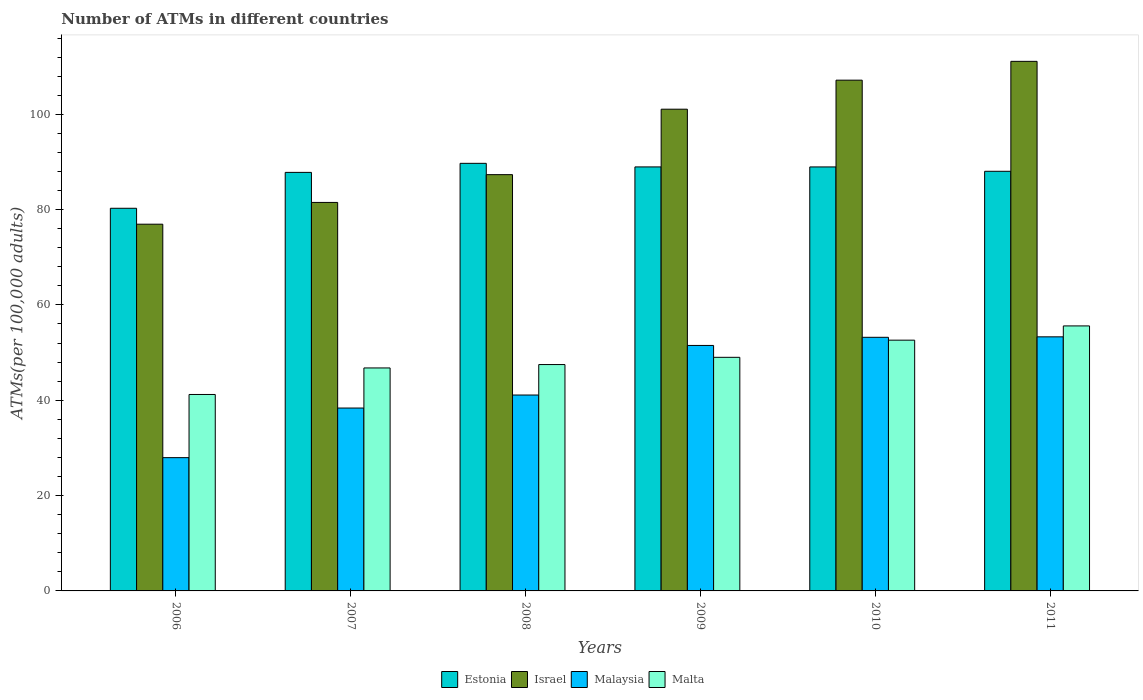How many groups of bars are there?
Give a very brief answer. 6. Are the number of bars per tick equal to the number of legend labels?
Offer a very short reply. Yes. Are the number of bars on each tick of the X-axis equal?
Ensure brevity in your answer.  Yes. How many bars are there on the 1st tick from the left?
Offer a terse response. 4. What is the label of the 4th group of bars from the left?
Your answer should be compact. 2009. In how many cases, is the number of bars for a given year not equal to the number of legend labels?
Provide a short and direct response. 0. What is the number of ATMs in Malta in 2006?
Your answer should be compact. 41.21. Across all years, what is the maximum number of ATMs in Malta?
Your response must be concise. 55.6. Across all years, what is the minimum number of ATMs in Estonia?
Your response must be concise. 80.28. In which year was the number of ATMs in Estonia minimum?
Your answer should be very brief. 2006. What is the total number of ATMs in Malta in the graph?
Your answer should be compact. 292.7. What is the difference between the number of ATMs in Israel in 2009 and that in 2011?
Your answer should be very brief. -10.04. What is the difference between the number of ATMs in Israel in 2007 and the number of ATMs in Malaysia in 2009?
Your answer should be very brief. 30. What is the average number of ATMs in Malaysia per year?
Your answer should be very brief. 44.24. In the year 2008, what is the difference between the number of ATMs in Israel and number of ATMs in Malaysia?
Provide a succinct answer. 46.24. In how many years, is the number of ATMs in Malta greater than 28?
Give a very brief answer. 6. What is the ratio of the number of ATMs in Israel in 2007 to that in 2009?
Your answer should be compact. 0.81. What is the difference between the highest and the second highest number of ATMs in Estonia?
Your answer should be very brief. 0.75. What is the difference between the highest and the lowest number of ATMs in Malaysia?
Offer a very short reply. 25.34. Is it the case that in every year, the sum of the number of ATMs in Estonia and number of ATMs in Israel is greater than the sum of number of ATMs in Malta and number of ATMs in Malaysia?
Offer a very short reply. Yes. What does the 4th bar from the left in 2008 represents?
Offer a very short reply. Malta. What does the 2nd bar from the right in 2009 represents?
Your answer should be very brief. Malaysia. Are all the bars in the graph horizontal?
Give a very brief answer. No. How many years are there in the graph?
Offer a very short reply. 6. Are the values on the major ticks of Y-axis written in scientific E-notation?
Ensure brevity in your answer.  No. Where does the legend appear in the graph?
Your answer should be compact. Bottom center. How many legend labels are there?
Your response must be concise. 4. How are the legend labels stacked?
Keep it short and to the point. Horizontal. What is the title of the graph?
Keep it short and to the point. Number of ATMs in different countries. Does "Haiti" appear as one of the legend labels in the graph?
Provide a short and direct response. No. What is the label or title of the Y-axis?
Ensure brevity in your answer.  ATMs(per 100,0 adults). What is the ATMs(per 100,000 adults) of Estonia in 2006?
Your answer should be compact. 80.28. What is the ATMs(per 100,000 adults) in Israel in 2006?
Offer a terse response. 76.94. What is the ATMs(per 100,000 adults) of Malaysia in 2006?
Ensure brevity in your answer.  27.96. What is the ATMs(per 100,000 adults) in Malta in 2006?
Provide a short and direct response. 41.21. What is the ATMs(per 100,000 adults) in Estonia in 2007?
Give a very brief answer. 87.81. What is the ATMs(per 100,000 adults) in Israel in 2007?
Provide a short and direct response. 81.5. What is the ATMs(per 100,000 adults) in Malaysia in 2007?
Offer a very short reply. 38.37. What is the ATMs(per 100,000 adults) of Malta in 2007?
Offer a very short reply. 46.78. What is the ATMs(per 100,000 adults) in Estonia in 2008?
Give a very brief answer. 89.71. What is the ATMs(per 100,000 adults) of Israel in 2008?
Your response must be concise. 87.33. What is the ATMs(per 100,000 adults) in Malaysia in 2008?
Make the answer very short. 41.1. What is the ATMs(per 100,000 adults) of Malta in 2008?
Your answer should be very brief. 47.49. What is the ATMs(per 100,000 adults) in Estonia in 2009?
Give a very brief answer. 88.96. What is the ATMs(per 100,000 adults) of Israel in 2009?
Your answer should be compact. 101.06. What is the ATMs(per 100,000 adults) in Malaysia in 2009?
Offer a terse response. 51.5. What is the ATMs(per 100,000 adults) of Malta in 2009?
Your response must be concise. 49.01. What is the ATMs(per 100,000 adults) in Estonia in 2010?
Offer a terse response. 88.95. What is the ATMs(per 100,000 adults) of Israel in 2010?
Offer a very short reply. 107.16. What is the ATMs(per 100,000 adults) in Malaysia in 2010?
Your answer should be compact. 53.21. What is the ATMs(per 100,000 adults) of Malta in 2010?
Offer a terse response. 52.61. What is the ATMs(per 100,000 adults) of Estonia in 2011?
Your answer should be compact. 88.04. What is the ATMs(per 100,000 adults) in Israel in 2011?
Your answer should be very brief. 111.1. What is the ATMs(per 100,000 adults) of Malaysia in 2011?
Offer a terse response. 53.31. What is the ATMs(per 100,000 adults) in Malta in 2011?
Your answer should be very brief. 55.6. Across all years, what is the maximum ATMs(per 100,000 adults) of Estonia?
Give a very brief answer. 89.71. Across all years, what is the maximum ATMs(per 100,000 adults) of Israel?
Make the answer very short. 111.1. Across all years, what is the maximum ATMs(per 100,000 adults) of Malaysia?
Make the answer very short. 53.31. Across all years, what is the maximum ATMs(per 100,000 adults) of Malta?
Provide a short and direct response. 55.6. Across all years, what is the minimum ATMs(per 100,000 adults) of Estonia?
Your answer should be very brief. 80.28. Across all years, what is the minimum ATMs(per 100,000 adults) in Israel?
Your response must be concise. 76.94. Across all years, what is the minimum ATMs(per 100,000 adults) of Malaysia?
Provide a short and direct response. 27.96. Across all years, what is the minimum ATMs(per 100,000 adults) of Malta?
Offer a terse response. 41.21. What is the total ATMs(per 100,000 adults) of Estonia in the graph?
Offer a very short reply. 523.74. What is the total ATMs(per 100,000 adults) in Israel in the graph?
Keep it short and to the point. 565.1. What is the total ATMs(per 100,000 adults) of Malaysia in the graph?
Ensure brevity in your answer.  265.44. What is the total ATMs(per 100,000 adults) of Malta in the graph?
Offer a very short reply. 292.7. What is the difference between the ATMs(per 100,000 adults) in Estonia in 2006 and that in 2007?
Your response must be concise. -7.53. What is the difference between the ATMs(per 100,000 adults) in Israel in 2006 and that in 2007?
Give a very brief answer. -4.57. What is the difference between the ATMs(per 100,000 adults) of Malaysia in 2006 and that in 2007?
Ensure brevity in your answer.  -10.41. What is the difference between the ATMs(per 100,000 adults) in Malta in 2006 and that in 2007?
Keep it short and to the point. -5.57. What is the difference between the ATMs(per 100,000 adults) of Estonia in 2006 and that in 2008?
Offer a very short reply. -9.43. What is the difference between the ATMs(per 100,000 adults) of Israel in 2006 and that in 2008?
Keep it short and to the point. -10.4. What is the difference between the ATMs(per 100,000 adults) of Malaysia in 2006 and that in 2008?
Ensure brevity in your answer.  -13.14. What is the difference between the ATMs(per 100,000 adults) in Malta in 2006 and that in 2008?
Your answer should be compact. -6.28. What is the difference between the ATMs(per 100,000 adults) of Estonia in 2006 and that in 2009?
Offer a very short reply. -8.68. What is the difference between the ATMs(per 100,000 adults) of Israel in 2006 and that in 2009?
Your answer should be very brief. -24.13. What is the difference between the ATMs(per 100,000 adults) of Malaysia in 2006 and that in 2009?
Your answer should be very brief. -23.54. What is the difference between the ATMs(per 100,000 adults) in Malta in 2006 and that in 2009?
Your answer should be very brief. -7.79. What is the difference between the ATMs(per 100,000 adults) of Estonia in 2006 and that in 2010?
Your response must be concise. -8.68. What is the difference between the ATMs(per 100,000 adults) of Israel in 2006 and that in 2010?
Provide a succinct answer. -30.22. What is the difference between the ATMs(per 100,000 adults) in Malaysia in 2006 and that in 2010?
Provide a short and direct response. -25.25. What is the difference between the ATMs(per 100,000 adults) in Malta in 2006 and that in 2010?
Provide a short and direct response. -11.4. What is the difference between the ATMs(per 100,000 adults) in Estonia in 2006 and that in 2011?
Offer a very short reply. -7.76. What is the difference between the ATMs(per 100,000 adults) in Israel in 2006 and that in 2011?
Your response must be concise. -34.16. What is the difference between the ATMs(per 100,000 adults) of Malaysia in 2006 and that in 2011?
Offer a terse response. -25.34. What is the difference between the ATMs(per 100,000 adults) in Malta in 2006 and that in 2011?
Your response must be concise. -14.38. What is the difference between the ATMs(per 100,000 adults) of Estonia in 2007 and that in 2008?
Ensure brevity in your answer.  -1.9. What is the difference between the ATMs(per 100,000 adults) of Israel in 2007 and that in 2008?
Keep it short and to the point. -5.83. What is the difference between the ATMs(per 100,000 adults) in Malaysia in 2007 and that in 2008?
Keep it short and to the point. -2.73. What is the difference between the ATMs(per 100,000 adults) of Malta in 2007 and that in 2008?
Your response must be concise. -0.71. What is the difference between the ATMs(per 100,000 adults) in Estonia in 2007 and that in 2009?
Offer a very short reply. -1.15. What is the difference between the ATMs(per 100,000 adults) of Israel in 2007 and that in 2009?
Your answer should be very brief. -19.56. What is the difference between the ATMs(per 100,000 adults) of Malaysia in 2007 and that in 2009?
Your answer should be compact. -13.13. What is the difference between the ATMs(per 100,000 adults) in Malta in 2007 and that in 2009?
Keep it short and to the point. -2.23. What is the difference between the ATMs(per 100,000 adults) of Estonia in 2007 and that in 2010?
Ensure brevity in your answer.  -1.15. What is the difference between the ATMs(per 100,000 adults) of Israel in 2007 and that in 2010?
Your answer should be very brief. -25.65. What is the difference between the ATMs(per 100,000 adults) in Malaysia in 2007 and that in 2010?
Provide a succinct answer. -14.84. What is the difference between the ATMs(per 100,000 adults) in Malta in 2007 and that in 2010?
Make the answer very short. -5.83. What is the difference between the ATMs(per 100,000 adults) in Estonia in 2007 and that in 2011?
Your answer should be compact. -0.23. What is the difference between the ATMs(per 100,000 adults) of Israel in 2007 and that in 2011?
Your answer should be compact. -29.6. What is the difference between the ATMs(per 100,000 adults) in Malaysia in 2007 and that in 2011?
Make the answer very short. -14.94. What is the difference between the ATMs(per 100,000 adults) of Malta in 2007 and that in 2011?
Your answer should be very brief. -8.82. What is the difference between the ATMs(per 100,000 adults) in Estonia in 2008 and that in 2009?
Provide a short and direct response. 0.75. What is the difference between the ATMs(per 100,000 adults) of Israel in 2008 and that in 2009?
Your answer should be compact. -13.73. What is the difference between the ATMs(per 100,000 adults) of Malaysia in 2008 and that in 2009?
Make the answer very short. -10.4. What is the difference between the ATMs(per 100,000 adults) in Malta in 2008 and that in 2009?
Your response must be concise. -1.52. What is the difference between the ATMs(per 100,000 adults) in Estonia in 2008 and that in 2010?
Offer a terse response. 0.75. What is the difference between the ATMs(per 100,000 adults) in Israel in 2008 and that in 2010?
Offer a very short reply. -19.82. What is the difference between the ATMs(per 100,000 adults) of Malaysia in 2008 and that in 2010?
Your answer should be very brief. -12.11. What is the difference between the ATMs(per 100,000 adults) in Malta in 2008 and that in 2010?
Provide a short and direct response. -5.12. What is the difference between the ATMs(per 100,000 adults) in Estonia in 2008 and that in 2011?
Provide a succinct answer. 1.67. What is the difference between the ATMs(per 100,000 adults) of Israel in 2008 and that in 2011?
Your answer should be very brief. -23.77. What is the difference between the ATMs(per 100,000 adults) in Malaysia in 2008 and that in 2011?
Your answer should be very brief. -12.21. What is the difference between the ATMs(per 100,000 adults) in Malta in 2008 and that in 2011?
Provide a succinct answer. -8.11. What is the difference between the ATMs(per 100,000 adults) in Estonia in 2009 and that in 2010?
Your answer should be compact. 0. What is the difference between the ATMs(per 100,000 adults) of Israel in 2009 and that in 2010?
Your answer should be very brief. -6.09. What is the difference between the ATMs(per 100,000 adults) of Malaysia in 2009 and that in 2010?
Your answer should be compact. -1.71. What is the difference between the ATMs(per 100,000 adults) in Malta in 2009 and that in 2010?
Your answer should be compact. -3.6. What is the difference between the ATMs(per 100,000 adults) in Estonia in 2009 and that in 2011?
Give a very brief answer. 0.92. What is the difference between the ATMs(per 100,000 adults) in Israel in 2009 and that in 2011?
Offer a very short reply. -10.04. What is the difference between the ATMs(per 100,000 adults) in Malaysia in 2009 and that in 2011?
Provide a succinct answer. -1.81. What is the difference between the ATMs(per 100,000 adults) of Malta in 2009 and that in 2011?
Offer a terse response. -6.59. What is the difference between the ATMs(per 100,000 adults) in Estonia in 2010 and that in 2011?
Provide a succinct answer. 0.92. What is the difference between the ATMs(per 100,000 adults) in Israel in 2010 and that in 2011?
Offer a very short reply. -3.95. What is the difference between the ATMs(per 100,000 adults) in Malaysia in 2010 and that in 2011?
Your answer should be very brief. -0.1. What is the difference between the ATMs(per 100,000 adults) of Malta in 2010 and that in 2011?
Ensure brevity in your answer.  -2.99. What is the difference between the ATMs(per 100,000 adults) of Estonia in 2006 and the ATMs(per 100,000 adults) of Israel in 2007?
Your answer should be very brief. -1.23. What is the difference between the ATMs(per 100,000 adults) of Estonia in 2006 and the ATMs(per 100,000 adults) of Malaysia in 2007?
Offer a terse response. 41.91. What is the difference between the ATMs(per 100,000 adults) of Estonia in 2006 and the ATMs(per 100,000 adults) of Malta in 2007?
Provide a succinct answer. 33.5. What is the difference between the ATMs(per 100,000 adults) in Israel in 2006 and the ATMs(per 100,000 adults) in Malaysia in 2007?
Offer a terse response. 38.57. What is the difference between the ATMs(per 100,000 adults) in Israel in 2006 and the ATMs(per 100,000 adults) in Malta in 2007?
Ensure brevity in your answer.  30.16. What is the difference between the ATMs(per 100,000 adults) of Malaysia in 2006 and the ATMs(per 100,000 adults) of Malta in 2007?
Your response must be concise. -18.82. What is the difference between the ATMs(per 100,000 adults) in Estonia in 2006 and the ATMs(per 100,000 adults) in Israel in 2008?
Your response must be concise. -7.06. What is the difference between the ATMs(per 100,000 adults) in Estonia in 2006 and the ATMs(per 100,000 adults) in Malaysia in 2008?
Give a very brief answer. 39.18. What is the difference between the ATMs(per 100,000 adults) in Estonia in 2006 and the ATMs(per 100,000 adults) in Malta in 2008?
Make the answer very short. 32.79. What is the difference between the ATMs(per 100,000 adults) of Israel in 2006 and the ATMs(per 100,000 adults) of Malaysia in 2008?
Provide a short and direct response. 35.84. What is the difference between the ATMs(per 100,000 adults) in Israel in 2006 and the ATMs(per 100,000 adults) in Malta in 2008?
Your answer should be very brief. 29.45. What is the difference between the ATMs(per 100,000 adults) of Malaysia in 2006 and the ATMs(per 100,000 adults) of Malta in 2008?
Your answer should be very brief. -19.53. What is the difference between the ATMs(per 100,000 adults) in Estonia in 2006 and the ATMs(per 100,000 adults) in Israel in 2009?
Your answer should be compact. -20.79. What is the difference between the ATMs(per 100,000 adults) in Estonia in 2006 and the ATMs(per 100,000 adults) in Malaysia in 2009?
Provide a succinct answer. 28.78. What is the difference between the ATMs(per 100,000 adults) of Estonia in 2006 and the ATMs(per 100,000 adults) of Malta in 2009?
Keep it short and to the point. 31.27. What is the difference between the ATMs(per 100,000 adults) in Israel in 2006 and the ATMs(per 100,000 adults) in Malaysia in 2009?
Keep it short and to the point. 25.44. What is the difference between the ATMs(per 100,000 adults) of Israel in 2006 and the ATMs(per 100,000 adults) of Malta in 2009?
Your response must be concise. 27.93. What is the difference between the ATMs(per 100,000 adults) in Malaysia in 2006 and the ATMs(per 100,000 adults) in Malta in 2009?
Provide a short and direct response. -21.05. What is the difference between the ATMs(per 100,000 adults) in Estonia in 2006 and the ATMs(per 100,000 adults) in Israel in 2010?
Make the answer very short. -26.88. What is the difference between the ATMs(per 100,000 adults) of Estonia in 2006 and the ATMs(per 100,000 adults) of Malaysia in 2010?
Your answer should be very brief. 27.07. What is the difference between the ATMs(per 100,000 adults) in Estonia in 2006 and the ATMs(per 100,000 adults) in Malta in 2010?
Provide a succinct answer. 27.67. What is the difference between the ATMs(per 100,000 adults) in Israel in 2006 and the ATMs(per 100,000 adults) in Malaysia in 2010?
Keep it short and to the point. 23.73. What is the difference between the ATMs(per 100,000 adults) in Israel in 2006 and the ATMs(per 100,000 adults) in Malta in 2010?
Give a very brief answer. 24.33. What is the difference between the ATMs(per 100,000 adults) of Malaysia in 2006 and the ATMs(per 100,000 adults) of Malta in 2010?
Offer a very short reply. -24.65. What is the difference between the ATMs(per 100,000 adults) in Estonia in 2006 and the ATMs(per 100,000 adults) in Israel in 2011?
Your answer should be very brief. -30.82. What is the difference between the ATMs(per 100,000 adults) in Estonia in 2006 and the ATMs(per 100,000 adults) in Malaysia in 2011?
Your answer should be very brief. 26.97. What is the difference between the ATMs(per 100,000 adults) in Estonia in 2006 and the ATMs(per 100,000 adults) in Malta in 2011?
Offer a terse response. 24.68. What is the difference between the ATMs(per 100,000 adults) in Israel in 2006 and the ATMs(per 100,000 adults) in Malaysia in 2011?
Give a very brief answer. 23.63. What is the difference between the ATMs(per 100,000 adults) of Israel in 2006 and the ATMs(per 100,000 adults) of Malta in 2011?
Provide a succinct answer. 21.34. What is the difference between the ATMs(per 100,000 adults) in Malaysia in 2006 and the ATMs(per 100,000 adults) in Malta in 2011?
Ensure brevity in your answer.  -27.64. What is the difference between the ATMs(per 100,000 adults) in Estonia in 2007 and the ATMs(per 100,000 adults) in Israel in 2008?
Your response must be concise. 0.47. What is the difference between the ATMs(per 100,000 adults) in Estonia in 2007 and the ATMs(per 100,000 adults) in Malaysia in 2008?
Keep it short and to the point. 46.71. What is the difference between the ATMs(per 100,000 adults) in Estonia in 2007 and the ATMs(per 100,000 adults) in Malta in 2008?
Ensure brevity in your answer.  40.32. What is the difference between the ATMs(per 100,000 adults) of Israel in 2007 and the ATMs(per 100,000 adults) of Malaysia in 2008?
Provide a short and direct response. 40.41. What is the difference between the ATMs(per 100,000 adults) of Israel in 2007 and the ATMs(per 100,000 adults) of Malta in 2008?
Your answer should be very brief. 34.01. What is the difference between the ATMs(per 100,000 adults) in Malaysia in 2007 and the ATMs(per 100,000 adults) in Malta in 2008?
Offer a terse response. -9.12. What is the difference between the ATMs(per 100,000 adults) of Estonia in 2007 and the ATMs(per 100,000 adults) of Israel in 2009?
Make the answer very short. -13.26. What is the difference between the ATMs(per 100,000 adults) in Estonia in 2007 and the ATMs(per 100,000 adults) in Malaysia in 2009?
Offer a terse response. 36.31. What is the difference between the ATMs(per 100,000 adults) of Estonia in 2007 and the ATMs(per 100,000 adults) of Malta in 2009?
Provide a short and direct response. 38.8. What is the difference between the ATMs(per 100,000 adults) in Israel in 2007 and the ATMs(per 100,000 adults) in Malaysia in 2009?
Give a very brief answer. 30. What is the difference between the ATMs(per 100,000 adults) in Israel in 2007 and the ATMs(per 100,000 adults) in Malta in 2009?
Offer a very short reply. 32.5. What is the difference between the ATMs(per 100,000 adults) in Malaysia in 2007 and the ATMs(per 100,000 adults) in Malta in 2009?
Your response must be concise. -10.64. What is the difference between the ATMs(per 100,000 adults) in Estonia in 2007 and the ATMs(per 100,000 adults) in Israel in 2010?
Make the answer very short. -19.35. What is the difference between the ATMs(per 100,000 adults) of Estonia in 2007 and the ATMs(per 100,000 adults) of Malaysia in 2010?
Provide a short and direct response. 34.6. What is the difference between the ATMs(per 100,000 adults) in Estonia in 2007 and the ATMs(per 100,000 adults) in Malta in 2010?
Your response must be concise. 35.2. What is the difference between the ATMs(per 100,000 adults) of Israel in 2007 and the ATMs(per 100,000 adults) of Malaysia in 2010?
Offer a terse response. 28.3. What is the difference between the ATMs(per 100,000 adults) in Israel in 2007 and the ATMs(per 100,000 adults) in Malta in 2010?
Provide a succinct answer. 28.9. What is the difference between the ATMs(per 100,000 adults) in Malaysia in 2007 and the ATMs(per 100,000 adults) in Malta in 2010?
Offer a terse response. -14.24. What is the difference between the ATMs(per 100,000 adults) in Estonia in 2007 and the ATMs(per 100,000 adults) in Israel in 2011?
Provide a short and direct response. -23.29. What is the difference between the ATMs(per 100,000 adults) of Estonia in 2007 and the ATMs(per 100,000 adults) of Malaysia in 2011?
Give a very brief answer. 34.5. What is the difference between the ATMs(per 100,000 adults) of Estonia in 2007 and the ATMs(per 100,000 adults) of Malta in 2011?
Offer a very short reply. 32.21. What is the difference between the ATMs(per 100,000 adults) in Israel in 2007 and the ATMs(per 100,000 adults) in Malaysia in 2011?
Offer a very short reply. 28.2. What is the difference between the ATMs(per 100,000 adults) in Israel in 2007 and the ATMs(per 100,000 adults) in Malta in 2011?
Offer a very short reply. 25.91. What is the difference between the ATMs(per 100,000 adults) in Malaysia in 2007 and the ATMs(per 100,000 adults) in Malta in 2011?
Your answer should be very brief. -17.23. What is the difference between the ATMs(per 100,000 adults) of Estonia in 2008 and the ATMs(per 100,000 adults) of Israel in 2009?
Give a very brief answer. -11.36. What is the difference between the ATMs(per 100,000 adults) in Estonia in 2008 and the ATMs(per 100,000 adults) in Malaysia in 2009?
Your answer should be compact. 38.21. What is the difference between the ATMs(per 100,000 adults) in Estonia in 2008 and the ATMs(per 100,000 adults) in Malta in 2009?
Offer a terse response. 40.7. What is the difference between the ATMs(per 100,000 adults) in Israel in 2008 and the ATMs(per 100,000 adults) in Malaysia in 2009?
Your response must be concise. 35.83. What is the difference between the ATMs(per 100,000 adults) of Israel in 2008 and the ATMs(per 100,000 adults) of Malta in 2009?
Ensure brevity in your answer.  38.33. What is the difference between the ATMs(per 100,000 adults) of Malaysia in 2008 and the ATMs(per 100,000 adults) of Malta in 2009?
Your answer should be very brief. -7.91. What is the difference between the ATMs(per 100,000 adults) of Estonia in 2008 and the ATMs(per 100,000 adults) of Israel in 2010?
Your answer should be very brief. -17.45. What is the difference between the ATMs(per 100,000 adults) of Estonia in 2008 and the ATMs(per 100,000 adults) of Malaysia in 2010?
Offer a very short reply. 36.5. What is the difference between the ATMs(per 100,000 adults) of Estonia in 2008 and the ATMs(per 100,000 adults) of Malta in 2010?
Your response must be concise. 37.1. What is the difference between the ATMs(per 100,000 adults) in Israel in 2008 and the ATMs(per 100,000 adults) in Malaysia in 2010?
Your answer should be very brief. 34.13. What is the difference between the ATMs(per 100,000 adults) of Israel in 2008 and the ATMs(per 100,000 adults) of Malta in 2010?
Give a very brief answer. 34.72. What is the difference between the ATMs(per 100,000 adults) in Malaysia in 2008 and the ATMs(per 100,000 adults) in Malta in 2010?
Keep it short and to the point. -11.51. What is the difference between the ATMs(per 100,000 adults) of Estonia in 2008 and the ATMs(per 100,000 adults) of Israel in 2011?
Your answer should be very brief. -21.4. What is the difference between the ATMs(per 100,000 adults) of Estonia in 2008 and the ATMs(per 100,000 adults) of Malaysia in 2011?
Your answer should be compact. 36.4. What is the difference between the ATMs(per 100,000 adults) of Estonia in 2008 and the ATMs(per 100,000 adults) of Malta in 2011?
Make the answer very short. 34.11. What is the difference between the ATMs(per 100,000 adults) in Israel in 2008 and the ATMs(per 100,000 adults) in Malaysia in 2011?
Provide a short and direct response. 34.03. What is the difference between the ATMs(per 100,000 adults) in Israel in 2008 and the ATMs(per 100,000 adults) in Malta in 2011?
Offer a terse response. 31.74. What is the difference between the ATMs(per 100,000 adults) of Malaysia in 2008 and the ATMs(per 100,000 adults) of Malta in 2011?
Give a very brief answer. -14.5. What is the difference between the ATMs(per 100,000 adults) of Estonia in 2009 and the ATMs(per 100,000 adults) of Israel in 2010?
Offer a terse response. -18.2. What is the difference between the ATMs(per 100,000 adults) of Estonia in 2009 and the ATMs(per 100,000 adults) of Malaysia in 2010?
Ensure brevity in your answer.  35.75. What is the difference between the ATMs(per 100,000 adults) of Estonia in 2009 and the ATMs(per 100,000 adults) of Malta in 2010?
Your answer should be very brief. 36.35. What is the difference between the ATMs(per 100,000 adults) in Israel in 2009 and the ATMs(per 100,000 adults) in Malaysia in 2010?
Provide a short and direct response. 47.86. What is the difference between the ATMs(per 100,000 adults) in Israel in 2009 and the ATMs(per 100,000 adults) in Malta in 2010?
Your response must be concise. 48.45. What is the difference between the ATMs(per 100,000 adults) of Malaysia in 2009 and the ATMs(per 100,000 adults) of Malta in 2010?
Ensure brevity in your answer.  -1.11. What is the difference between the ATMs(per 100,000 adults) in Estonia in 2009 and the ATMs(per 100,000 adults) in Israel in 2011?
Your response must be concise. -22.15. What is the difference between the ATMs(per 100,000 adults) in Estonia in 2009 and the ATMs(per 100,000 adults) in Malaysia in 2011?
Your answer should be very brief. 35.65. What is the difference between the ATMs(per 100,000 adults) in Estonia in 2009 and the ATMs(per 100,000 adults) in Malta in 2011?
Give a very brief answer. 33.36. What is the difference between the ATMs(per 100,000 adults) in Israel in 2009 and the ATMs(per 100,000 adults) in Malaysia in 2011?
Keep it short and to the point. 47.76. What is the difference between the ATMs(per 100,000 adults) of Israel in 2009 and the ATMs(per 100,000 adults) of Malta in 2011?
Provide a short and direct response. 45.47. What is the difference between the ATMs(per 100,000 adults) in Malaysia in 2009 and the ATMs(per 100,000 adults) in Malta in 2011?
Keep it short and to the point. -4.1. What is the difference between the ATMs(per 100,000 adults) in Estonia in 2010 and the ATMs(per 100,000 adults) in Israel in 2011?
Ensure brevity in your answer.  -22.15. What is the difference between the ATMs(per 100,000 adults) in Estonia in 2010 and the ATMs(per 100,000 adults) in Malaysia in 2011?
Provide a succinct answer. 35.65. What is the difference between the ATMs(per 100,000 adults) of Estonia in 2010 and the ATMs(per 100,000 adults) of Malta in 2011?
Provide a succinct answer. 33.36. What is the difference between the ATMs(per 100,000 adults) in Israel in 2010 and the ATMs(per 100,000 adults) in Malaysia in 2011?
Your answer should be compact. 53.85. What is the difference between the ATMs(per 100,000 adults) in Israel in 2010 and the ATMs(per 100,000 adults) in Malta in 2011?
Your answer should be compact. 51.56. What is the difference between the ATMs(per 100,000 adults) in Malaysia in 2010 and the ATMs(per 100,000 adults) in Malta in 2011?
Keep it short and to the point. -2.39. What is the average ATMs(per 100,000 adults) of Estonia per year?
Ensure brevity in your answer.  87.29. What is the average ATMs(per 100,000 adults) in Israel per year?
Your answer should be very brief. 94.18. What is the average ATMs(per 100,000 adults) in Malaysia per year?
Provide a short and direct response. 44.24. What is the average ATMs(per 100,000 adults) in Malta per year?
Your response must be concise. 48.78. In the year 2006, what is the difference between the ATMs(per 100,000 adults) in Estonia and ATMs(per 100,000 adults) in Israel?
Give a very brief answer. 3.34. In the year 2006, what is the difference between the ATMs(per 100,000 adults) of Estonia and ATMs(per 100,000 adults) of Malaysia?
Make the answer very short. 52.32. In the year 2006, what is the difference between the ATMs(per 100,000 adults) of Estonia and ATMs(per 100,000 adults) of Malta?
Your answer should be very brief. 39.06. In the year 2006, what is the difference between the ATMs(per 100,000 adults) of Israel and ATMs(per 100,000 adults) of Malaysia?
Offer a terse response. 48.98. In the year 2006, what is the difference between the ATMs(per 100,000 adults) in Israel and ATMs(per 100,000 adults) in Malta?
Provide a short and direct response. 35.72. In the year 2006, what is the difference between the ATMs(per 100,000 adults) of Malaysia and ATMs(per 100,000 adults) of Malta?
Provide a succinct answer. -13.25. In the year 2007, what is the difference between the ATMs(per 100,000 adults) in Estonia and ATMs(per 100,000 adults) in Israel?
Your answer should be compact. 6.3. In the year 2007, what is the difference between the ATMs(per 100,000 adults) of Estonia and ATMs(per 100,000 adults) of Malaysia?
Offer a very short reply. 49.44. In the year 2007, what is the difference between the ATMs(per 100,000 adults) of Estonia and ATMs(per 100,000 adults) of Malta?
Your answer should be compact. 41.03. In the year 2007, what is the difference between the ATMs(per 100,000 adults) of Israel and ATMs(per 100,000 adults) of Malaysia?
Offer a very short reply. 43.14. In the year 2007, what is the difference between the ATMs(per 100,000 adults) in Israel and ATMs(per 100,000 adults) in Malta?
Your answer should be compact. 34.72. In the year 2007, what is the difference between the ATMs(per 100,000 adults) in Malaysia and ATMs(per 100,000 adults) in Malta?
Provide a succinct answer. -8.41. In the year 2008, what is the difference between the ATMs(per 100,000 adults) in Estonia and ATMs(per 100,000 adults) in Israel?
Your response must be concise. 2.37. In the year 2008, what is the difference between the ATMs(per 100,000 adults) in Estonia and ATMs(per 100,000 adults) in Malaysia?
Give a very brief answer. 48.61. In the year 2008, what is the difference between the ATMs(per 100,000 adults) in Estonia and ATMs(per 100,000 adults) in Malta?
Provide a short and direct response. 42.22. In the year 2008, what is the difference between the ATMs(per 100,000 adults) of Israel and ATMs(per 100,000 adults) of Malaysia?
Provide a short and direct response. 46.24. In the year 2008, what is the difference between the ATMs(per 100,000 adults) of Israel and ATMs(per 100,000 adults) of Malta?
Make the answer very short. 39.84. In the year 2008, what is the difference between the ATMs(per 100,000 adults) of Malaysia and ATMs(per 100,000 adults) of Malta?
Your answer should be very brief. -6.39. In the year 2009, what is the difference between the ATMs(per 100,000 adults) of Estonia and ATMs(per 100,000 adults) of Israel?
Keep it short and to the point. -12.11. In the year 2009, what is the difference between the ATMs(per 100,000 adults) in Estonia and ATMs(per 100,000 adults) in Malaysia?
Provide a short and direct response. 37.46. In the year 2009, what is the difference between the ATMs(per 100,000 adults) of Estonia and ATMs(per 100,000 adults) of Malta?
Keep it short and to the point. 39.95. In the year 2009, what is the difference between the ATMs(per 100,000 adults) of Israel and ATMs(per 100,000 adults) of Malaysia?
Keep it short and to the point. 49.56. In the year 2009, what is the difference between the ATMs(per 100,000 adults) in Israel and ATMs(per 100,000 adults) in Malta?
Keep it short and to the point. 52.06. In the year 2009, what is the difference between the ATMs(per 100,000 adults) of Malaysia and ATMs(per 100,000 adults) of Malta?
Offer a very short reply. 2.49. In the year 2010, what is the difference between the ATMs(per 100,000 adults) in Estonia and ATMs(per 100,000 adults) in Israel?
Your answer should be compact. -18.2. In the year 2010, what is the difference between the ATMs(per 100,000 adults) in Estonia and ATMs(per 100,000 adults) in Malaysia?
Your answer should be very brief. 35.75. In the year 2010, what is the difference between the ATMs(per 100,000 adults) of Estonia and ATMs(per 100,000 adults) of Malta?
Give a very brief answer. 36.34. In the year 2010, what is the difference between the ATMs(per 100,000 adults) of Israel and ATMs(per 100,000 adults) of Malaysia?
Your answer should be compact. 53.95. In the year 2010, what is the difference between the ATMs(per 100,000 adults) of Israel and ATMs(per 100,000 adults) of Malta?
Offer a very short reply. 54.55. In the year 2010, what is the difference between the ATMs(per 100,000 adults) in Malaysia and ATMs(per 100,000 adults) in Malta?
Ensure brevity in your answer.  0.6. In the year 2011, what is the difference between the ATMs(per 100,000 adults) of Estonia and ATMs(per 100,000 adults) of Israel?
Offer a very short reply. -23.07. In the year 2011, what is the difference between the ATMs(per 100,000 adults) of Estonia and ATMs(per 100,000 adults) of Malaysia?
Your answer should be compact. 34.73. In the year 2011, what is the difference between the ATMs(per 100,000 adults) of Estonia and ATMs(per 100,000 adults) of Malta?
Your answer should be very brief. 32.44. In the year 2011, what is the difference between the ATMs(per 100,000 adults) in Israel and ATMs(per 100,000 adults) in Malaysia?
Your answer should be compact. 57.8. In the year 2011, what is the difference between the ATMs(per 100,000 adults) of Israel and ATMs(per 100,000 adults) of Malta?
Your answer should be very brief. 55.5. In the year 2011, what is the difference between the ATMs(per 100,000 adults) of Malaysia and ATMs(per 100,000 adults) of Malta?
Your response must be concise. -2.29. What is the ratio of the ATMs(per 100,000 adults) of Estonia in 2006 to that in 2007?
Your response must be concise. 0.91. What is the ratio of the ATMs(per 100,000 adults) in Israel in 2006 to that in 2007?
Give a very brief answer. 0.94. What is the ratio of the ATMs(per 100,000 adults) in Malaysia in 2006 to that in 2007?
Provide a succinct answer. 0.73. What is the ratio of the ATMs(per 100,000 adults) of Malta in 2006 to that in 2007?
Make the answer very short. 0.88. What is the ratio of the ATMs(per 100,000 adults) in Estonia in 2006 to that in 2008?
Offer a terse response. 0.89. What is the ratio of the ATMs(per 100,000 adults) in Israel in 2006 to that in 2008?
Offer a terse response. 0.88. What is the ratio of the ATMs(per 100,000 adults) in Malaysia in 2006 to that in 2008?
Provide a succinct answer. 0.68. What is the ratio of the ATMs(per 100,000 adults) of Malta in 2006 to that in 2008?
Your response must be concise. 0.87. What is the ratio of the ATMs(per 100,000 adults) in Estonia in 2006 to that in 2009?
Offer a very short reply. 0.9. What is the ratio of the ATMs(per 100,000 adults) in Israel in 2006 to that in 2009?
Offer a very short reply. 0.76. What is the ratio of the ATMs(per 100,000 adults) of Malaysia in 2006 to that in 2009?
Ensure brevity in your answer.  0.54. What is the ratio of the ATMs(per 100,000 adults) in Malta in 2006 to that in 2009?
Ensure brevity in your answer.  0.84. What is the ratio of the ATMs(per 100,000 adults) in Estonia in 2006 to that in 2010?
Keep it short and to the point. 0.9. What is the ratio of the ATMs(per 100,000 adults) of Israel in 2006 to that in 2010?
Make the answer very short. 0.72. What is the ratio of the ATMs(per 100,000 adults) of Malaysia in 2006 to that in 2010?
Your answer should be very brief. 0.53. What is the ratio of the ATMs(per 100,000 adults) in Malta in 2006 to that in 2010?
Provide a succinct answer. 0.78. What is the ratio of the ATMs(per 100,000 adults) in Estonia in 2006 to that in 2011?
Provide a succinct answer. 0.91. What is the ratio of the ATMs(per 100,000 adults) of Israel in 2006 to that in 2011?
Your answer should be compact. 0.69. What is the ratio of the ATMs(per 100,000 adults) of Malaysia in 2006 to that in 2011?
Offer a very short reply. 0.52. What is the ratio of the ATMs(per 100,000 adults) in Malta in 2006 to that in 2011?
Your answer should be very brief. 0.74. What is the ratio of the ATMs(per 100,000 adults) of Estonia in 2007 to that in 2008?
Provide a succinct answer. 0.98. What is the ratio of the ATMs(per 100,000 adults) in Israel in 2007 to that in 2008?
Offer a very short reply. 0.93. What is the ratio of the ATMs(per 100,000 adults) of Malaysia in 2007 to that in 2008?
Your answer should be compact. 0.93. What is the ratio of the ATMs(per 100,000 adults) in Malta in 2007 to that in 2008?
Provide a short and direct response. 0.99. What is the ratio of the ATMs(per 100,000 adults) of Estonia in 2007 to that in 2009?
Your answer should be compact. 0.99. What is the ratio of the ATMs(per 100,000 adults) in Israel in 2007 to that in 2009?
Your answer should be compact. 0.81. What is the ratio of the ATMs(per 100,000 adults) of Malaysia in 2007 to that in 2009?
Provide a short and direct response. 0.74. What is the ratio of the ATMs(per 100,000 adults) in Malta in 2007 to that in 2009?
Provide a short and direct response. 0.95. What is the ratio of the ATMs(per 100,000 adults) of Estonia in 2007 to that in 2010?
Provide a short and direct response. 0.99. What is the ratio of the ATMs(per 100,000 adults) of Israel in 2007 to that in 2010?
Your answer should be very brief. 0.76. What is the ratio of the ATMs(per 100,000 adults) of Malaysia in 2007 to that in 2010?
Keep it short and to the point. 0.72. What is the ratio of the ATMs(per 100,000 adults) in Malta in 2007 to that in 2010?
Offer a very short reply. 0.89. What is the ratio of the ATMs(per 100,000 adults) in Estonia in 2007 to that in 2011?
Offer a very short reply. 1. What is the ratio of the ATMs(per 100,000 adults) in Israel in 2007 to that in 2011?
Offer a terse response. 0.73. What is the ratio of the ATMs(per 100,000 adults) in Malaysia in 2007 to that in 2011?
Provide a succinct answer. 0.72. What is the ratio of the ATMs(per 100,000 adults) in Malta in 2007 to that in 2011?
Your answer should be very brief. 0.84. What is the ratio of the ATMs(per 100,000 adults) of Estonia in 2008 to that in 2009?
Offer a very short reply. 1.01. What is the ratio of the ATMs(per 100,000 adults) of Israel in 2008 to that in 2009?
Your answer should be very brief. 0.86. What is the ratio of the ATMs(per 100,000 adults) in Malaysia in 2008 to that in 2009?
Keep it short and to the point. 0.8. What is the ratio of the ATMs(per 100,000 adults) of Malta in 2008 to that in 2009?
Ensure brevity in your answer.  0.97. What is the ratio of the ATMs(per 100,000 adults) in Estonia in 2008 to that in 2010?
Your response must be concise. 1.01. What is the ratio of the ATMs(per 100,000 adults) of Israel in 2008 to that in 2010?
Provide a short and direct response. 0.81. What is the ratio of the ATMs(per 100,000 adults) in Malaysia in 2008 to that in 2010?
Ensure brevity in your answer.  0.77. What is the ratio of the ATMs(per 100,000 adults) in Malta in 2008 to that in 2010?
Offer a very short reply. 0.9. What is the ratio of the ATMs(per 100,000 adults) of Israel in 2008 to that in 2011?
Your answer should be very brief. 0.79. What is the ratio of the ATMs(per 100,000 adults) in Malaysia in 2008 to that in 2011?
Provide a short and direct response. 0.77. What is the ratio of the ATMs(per 100,000 adults) of Malta in 2008 to that in 2011?
Keep it short and to the point. 0.85. What is the ratio of the ATMs(per 100,000 adults) of Estonia in 2009 to that in 2010?
Provide a short and direct response. 1. What is the ratio of the ATMs(per 100,000 adults) in Israel in 2009 to that in 2010?
Your answer should be very brief. 0.94. What is the ratio of the ATMs(per 100,000 adults) in Malaysia in 2009 to that in 2010?
Provide a succinct answer. 0.97. What is the ratio of the ATMs(per 100,000 adults) in Malta in 2009 to that in 2010?
Your answer should be very brief. 0.93. What is the ratio of the ATMs(per 100,000 adults) in Estonia in 2009 to that in 2011?
Ensure brevity in your answer.  1.01. What is the ratio of the ATMs(per 100,000 adults) of Israel in 2009 to that in 2011?
Provide a short and direct response. 0.91. What is the ratio of the ATMs(per 100,000 adults) of Malaysia in 2009 to that in 2011?
Provide a succinct answer. 0.97. What is the ratio of the ATMs(per 100,000 adults) in Malta in 2009 to that in 2011?
Provide a short and direct response. 0.88. What is the ratio of the ATMs(per 100,000 adults) in Estonia in 2010 to that in 2011?
Your answer should be very brief. 1.01. What is the ratio of the ATMs(per 100,000 adults) in Israel in 2010 to that in 2011?
Provide a short and direct response. 0.96. What is the ratio of the ATMs(per 100,000 adults) of Malaysia in 2010 to that in 2011?
Give a very brief answer. 1. What is the ratio of the ATMs(per 100,000 adults) of Malta in 2010 to that in 2011?
Make the answer very short. 0.95. What is the difference between the highest and the second highest ATMs(per 100,000 adults) in Estonia?
Give a very brief answer. 0.75. What is the difference between the highest and the second highest ATMs(per 100,000 adults) of Israel?
Make the answer very short. 3.95. What is the difference between the highest and the second highest ATMs(per 100,000 adults) in Malaysia?
Ensure brevity in your answer.  0.1. What is the difference between the highest and the second highest ATMs(per 100,000 adults) in Malta?
Provide a short and direct response. 2.99. What is the difference between the highest and the lowest ATMs(per 100,000 adults) of Estonia?
Your answer should be very brief. 9.43. What is the difference between the highest and the lowest ATMs(per 100,000 adults) of Israel?
Give a very brief answer. 34.16. What is the difference between the highest and the lowest ATMs(per 100,000 adults) of Malaysia?
Keep it short and to the point. 25.34. What is the difference between the highest and the lowest ATMs(per 100,000 adults) in Malta?
Offer a terse response. 14.38. 